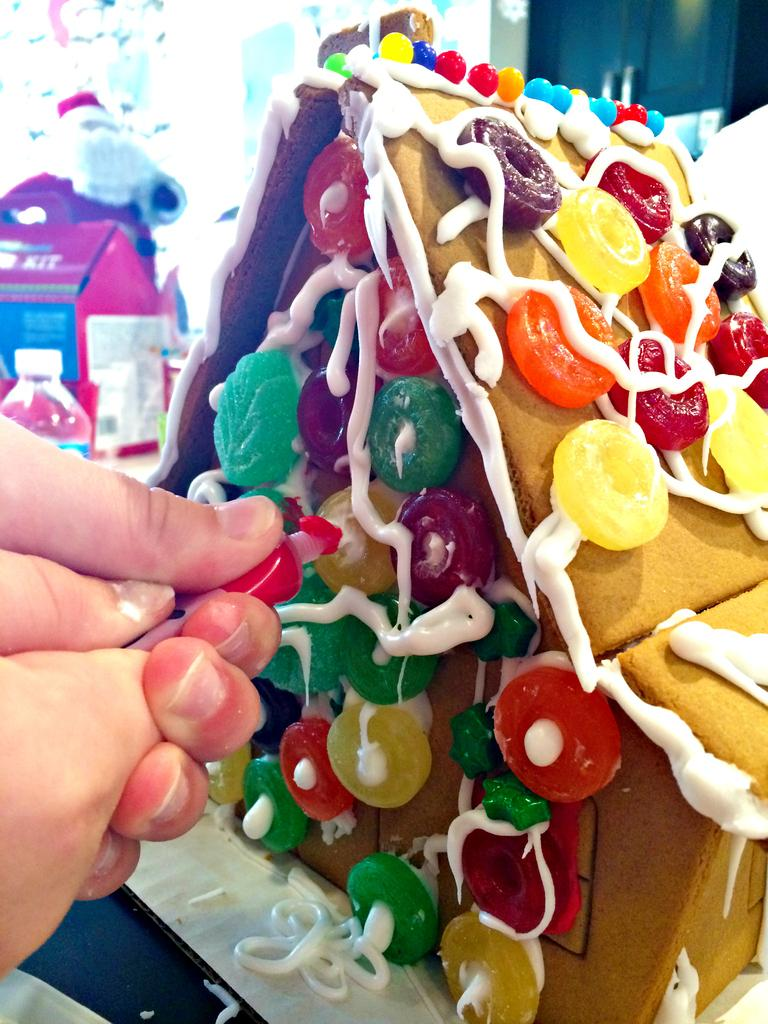What is the main subject of the image? There is a home made of cake in the image. What decorations are on the cake? The cake has candy and cream on it. Where is the cake located? The cake is on a table. What can be seen on the left side of the image? There is a hand with a cream tube on the left side of the image. What is visible in the background of the image? There is a water bottle and a glass wall in the background of the image. What type of organization does the scarecrow belong to in the image? There is no scarecrow present in the image. What topic are the people talking about in the image? There are no people talking in the image; it features a cake house and related elements. 